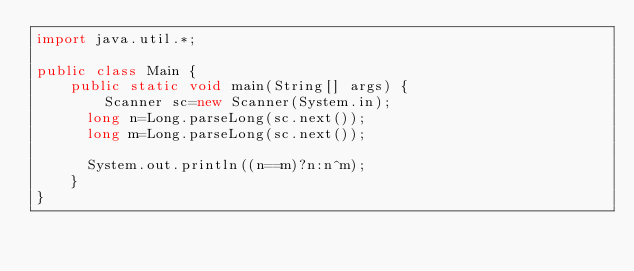<code> <loc_0><loc_0><loc_500><loc_500><_Java_>import java.util.*;

public class Main {
    public static void main(String[] args) {    
        Scanner sc=new Scanner(System.in);
      long n=Long.parseLong(sc.next());
      long m=Long.parseLong(sc.next());
      
      System.out.println((n==m)?n:n^m);
    }
}</code> 